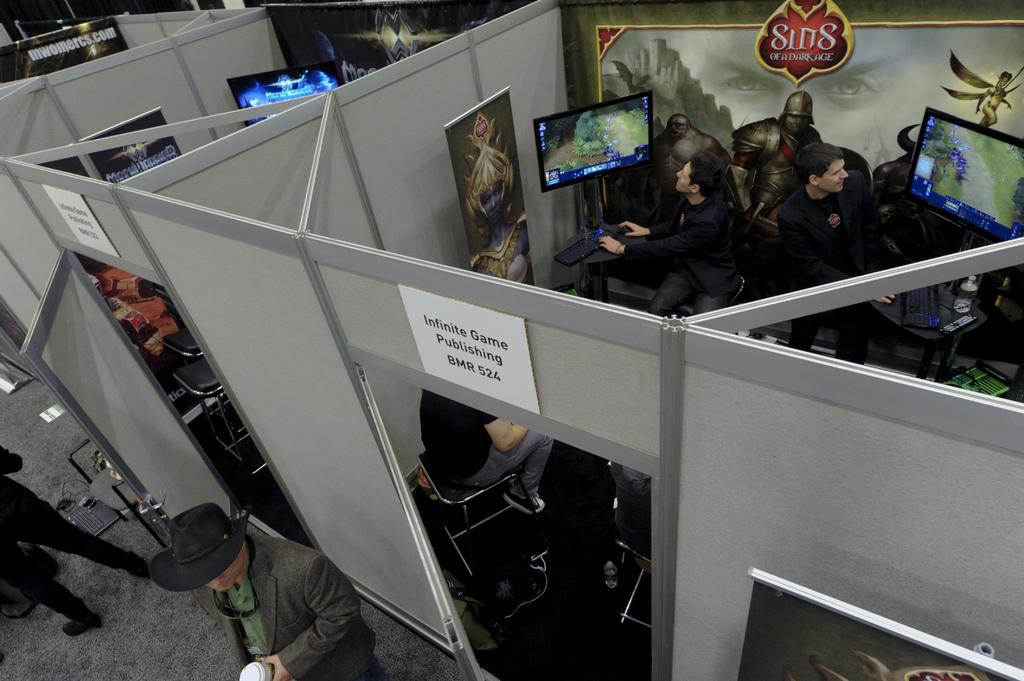Provide a one-sentence caption for the provided image. An Infinite Game Publishing cubicle with people inside on computers. 